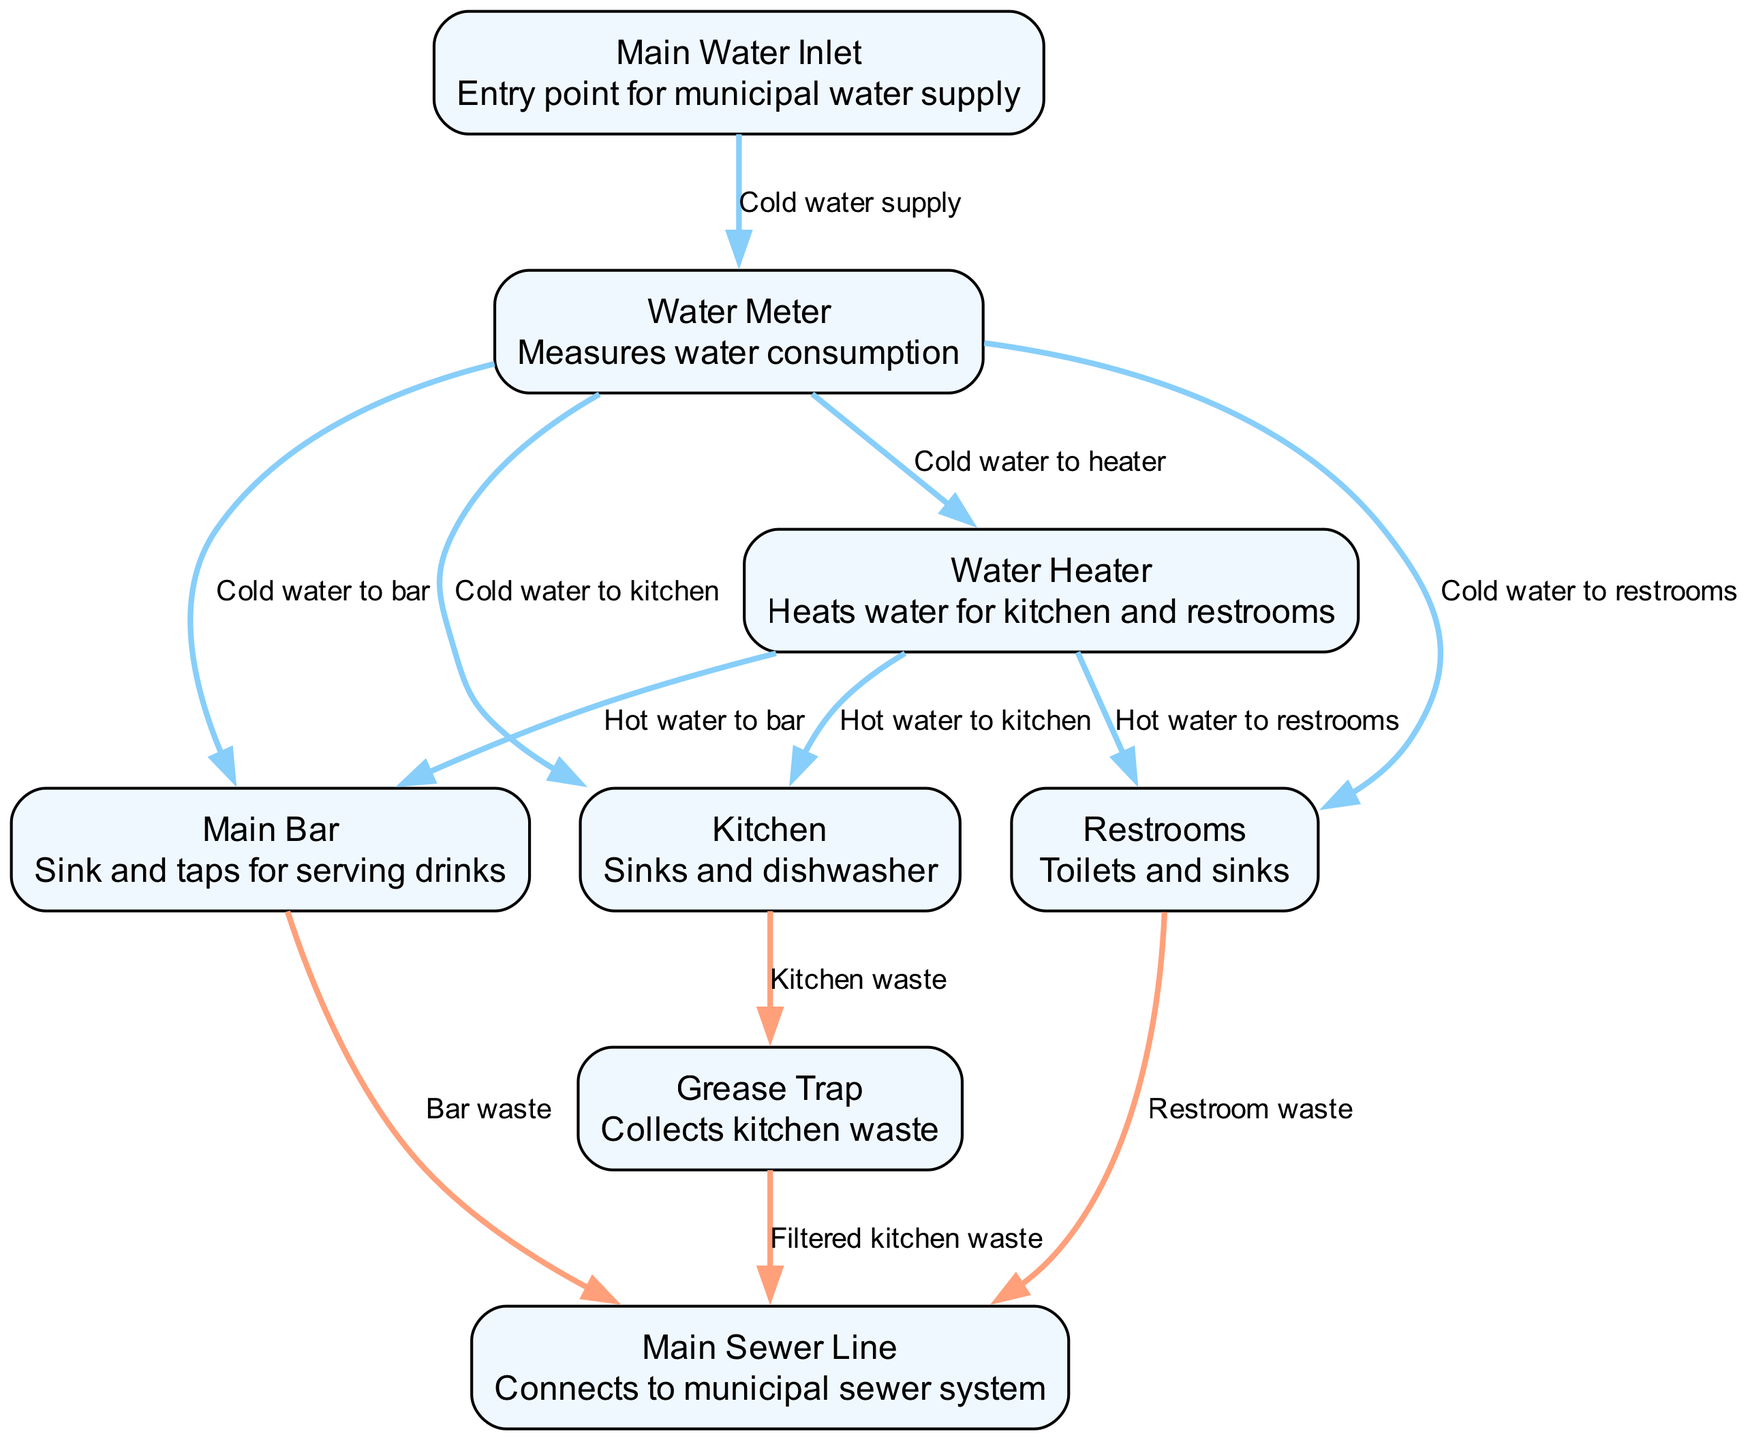What is the entry point for the municipal water supply? The "Main Water Inlet" node shows the entry point for the municipal water supply, as indicated in the description of this node.
Answer: Main Water Inlet How many nodes are present in the plumbing system diagram? By counting the items listed in the "nodes" section, there is a total of 8 distinct nodes representing various parts of the plumbing system.
Answer: 8 Which node is responsible for heating water? The "Water Heater" node is specifically identified as the component that heats water for both the kitchen and restrooms.
Answer: Water Heater What type of waste does the "Kitchen" produce? The "Kitchen" node is connected to the "Grease Trap" node, indicating that it produces "Kitchen waste" which is collected there.
Answer: Kitchen waste Which node connects to the municipal sewer system? The "Main Sewer Line" is labeled as the node that connects to the municipality's sewer system as described in its node description.
Answer: Main Sewer Line What is the flow of cold water to the restrooms? The flow of cold water proceeds from the "Water Meter" node directly to "Restrooms," indicating that they receive cold water supply.
Answer: Cold water to restrooms Which node collects the filtered kitchen waste? The "Grease Trap" node collects the filtered kitchen waste flowing from the "Kitchen" node, as indicated by the connection in the diagram.
Answer: Grease Trap What is the purpose of the "Water Meter"? The "Water Meter" node measures water consumption, as described in its description.
Answer: Measures water consumption How does hot water reach the bar from the Water Heater? The hot water is directed from the "Water Heater" to the "Main Bar" node, indicating that the bar receives its hot water supply from the heater.
Answer: Hot water to bar 